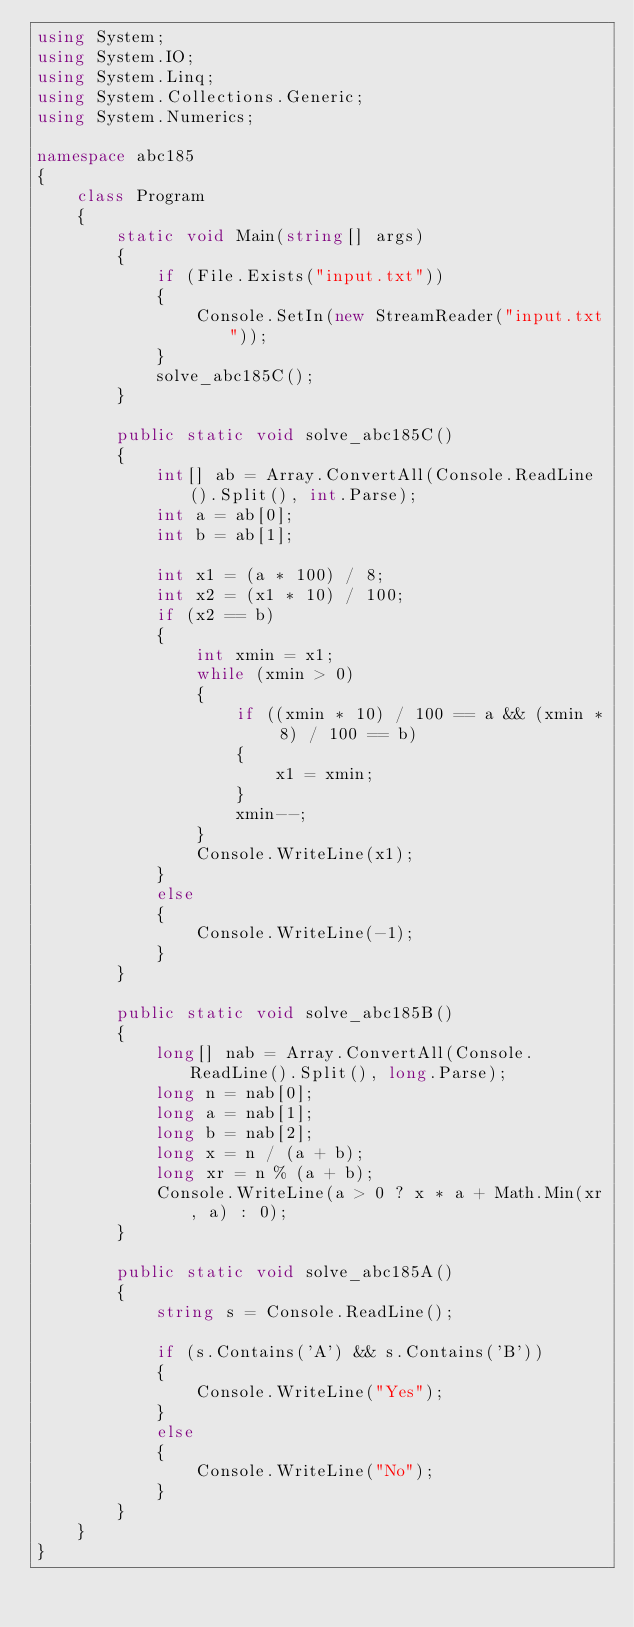<code> <loc_0><loc_0><loc_500><loc_500><_C#_>using System;
using System.IO;
using System.Linq;
using System.Collections.Generic;
using System.Numerics;

namespace abc185
{
    class Program
    {
        static void Main(string[] args)
        {
            if (File.Exists("input.txt"))
            {
                Console.SetIn(new StreamReader("input.txt"));
            }
			solve_abc185C();
        }

        public static void solve_abc185C()
        {
            int[] ab = Array.ConvertAll(Console.ReadLine().Split(), int.Parse);
            int a = ab[0];
            int b = ab[1];

            int x1 = (a * 100) / 8;
            int x2 = (x1 * 10) / 100;
            if (x2 == b)
            {
                int xmin = x1;
                while (xmin > 0)
                {
                    if ((xmin * 10) / 100 == a && (xmin * 8) / 100 == b)
                    {
                        x1 = xmin;
                    }
                    xmin--;
                }
                Console.WriteLine(x1);
            }
            else
            {
                Console.WriteLine(-1);
            }
        }

        public static void solve_abc185B()
        {
            long[] nab = Array.ConvertAll(Console.ReadLine().Split(), long.Parse);
            long n = nab[0];
            long a = nab[1];
            long b = nab[2];
            long x = n / (a + b);
            long xr = n % (a + b);
            Console.WriteLine(a > 0 ? x * a + Math.Min(xr, a) : 0);
        }

        public static void solve_abc185A()
        {
            string s = Console.ReadLine();

            if (s.Contains('A') && s.Contains('B'))
            {
                Console.WriteLine("Yes");
            }
            else
            {
                Console.WriteLine("No");
            }
        }
    }
}
</code> 